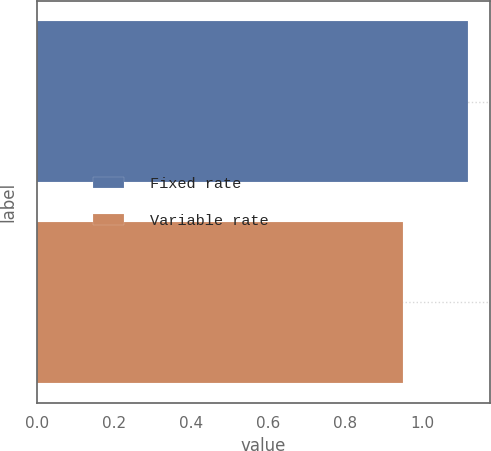Convert chart to OTSL. <chart><loc_0><loc_0><loc_500><loc_500><bar_chart><fcel>Fixed rate<fcel>Variable rate<nl><fcel>1.12<fcel>0.95<nl></chart> 